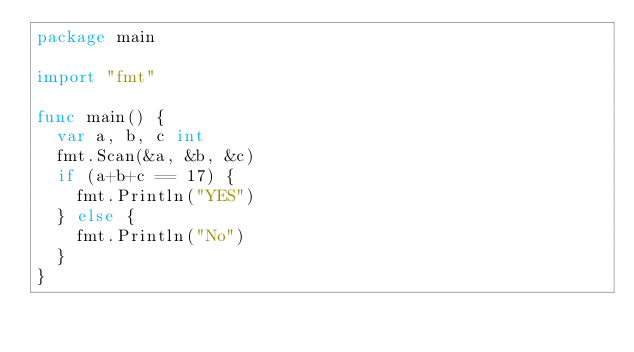<code> <loc_0><loc_0><loc_500><loc_500><_Go_>package main

import "fmt"

func main() {
  var a, b, c int
  fmt.Scan(&a, &b, &c)
  if (a+b+c == 17) {
    fmt.Println("YES")
  } else {
    fmt.Println("No")
  }
}</code> 